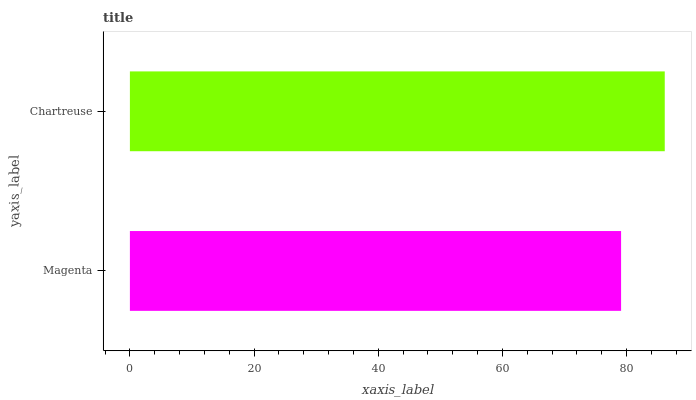Is Magenta the minimum?
Answer yes or no. Yes. Is Chartreuse the maximum?
Answer yes or no. Yes. Is Chartreuse the minimum?
Answer yes or no. No. Is Chartreuse greater than Magenta?
Answer yes or no. Yes. Is Magenta less than Chartreuse?
Answer yes or no. Yes. Is Magenta greater than Chartreuse?
Answer yes or no. No. Is Chartreuse less than Magenta?
Answer yes or no. No. Is Chartreuse the high median?
Answer yes or no. Yes. Is Magenta the low median?
Answer yes or no. Yes. Is Magenta the high median?
Answer yes or no. No. Is Chartreuse the low median?
Answer yes or no. No. 